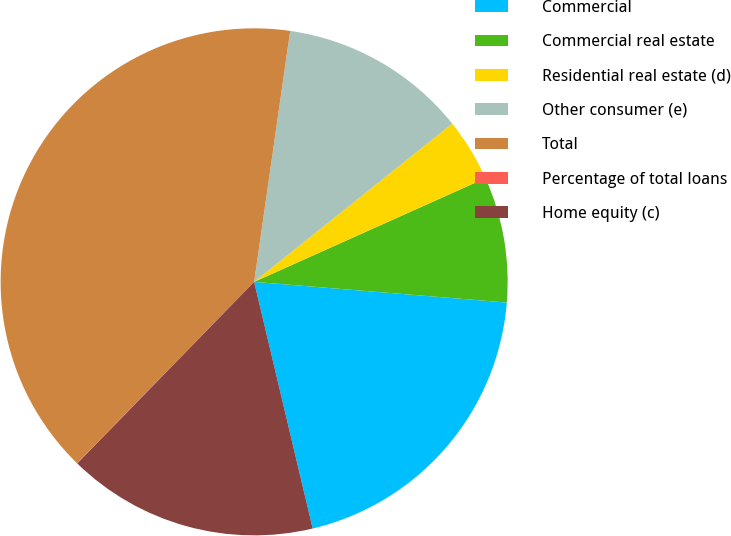<chart> <loc_0><loc_0><loc_500><loc_500><pie_chart><fcel>Commercial<fcel>Commercial real estate<fcel>Residential real estate (d)<fcel>Other consumer (e)<fcel>Total<fcel>Percentage of total loans<fcel>Home equity (c)<nl><fcel>19.99%<fcel>8.01%<fcel>4.02%<fcel>12.0%<fcel>39.96%<fcel>0.02%<fcel>16.0%<nl></chart> 